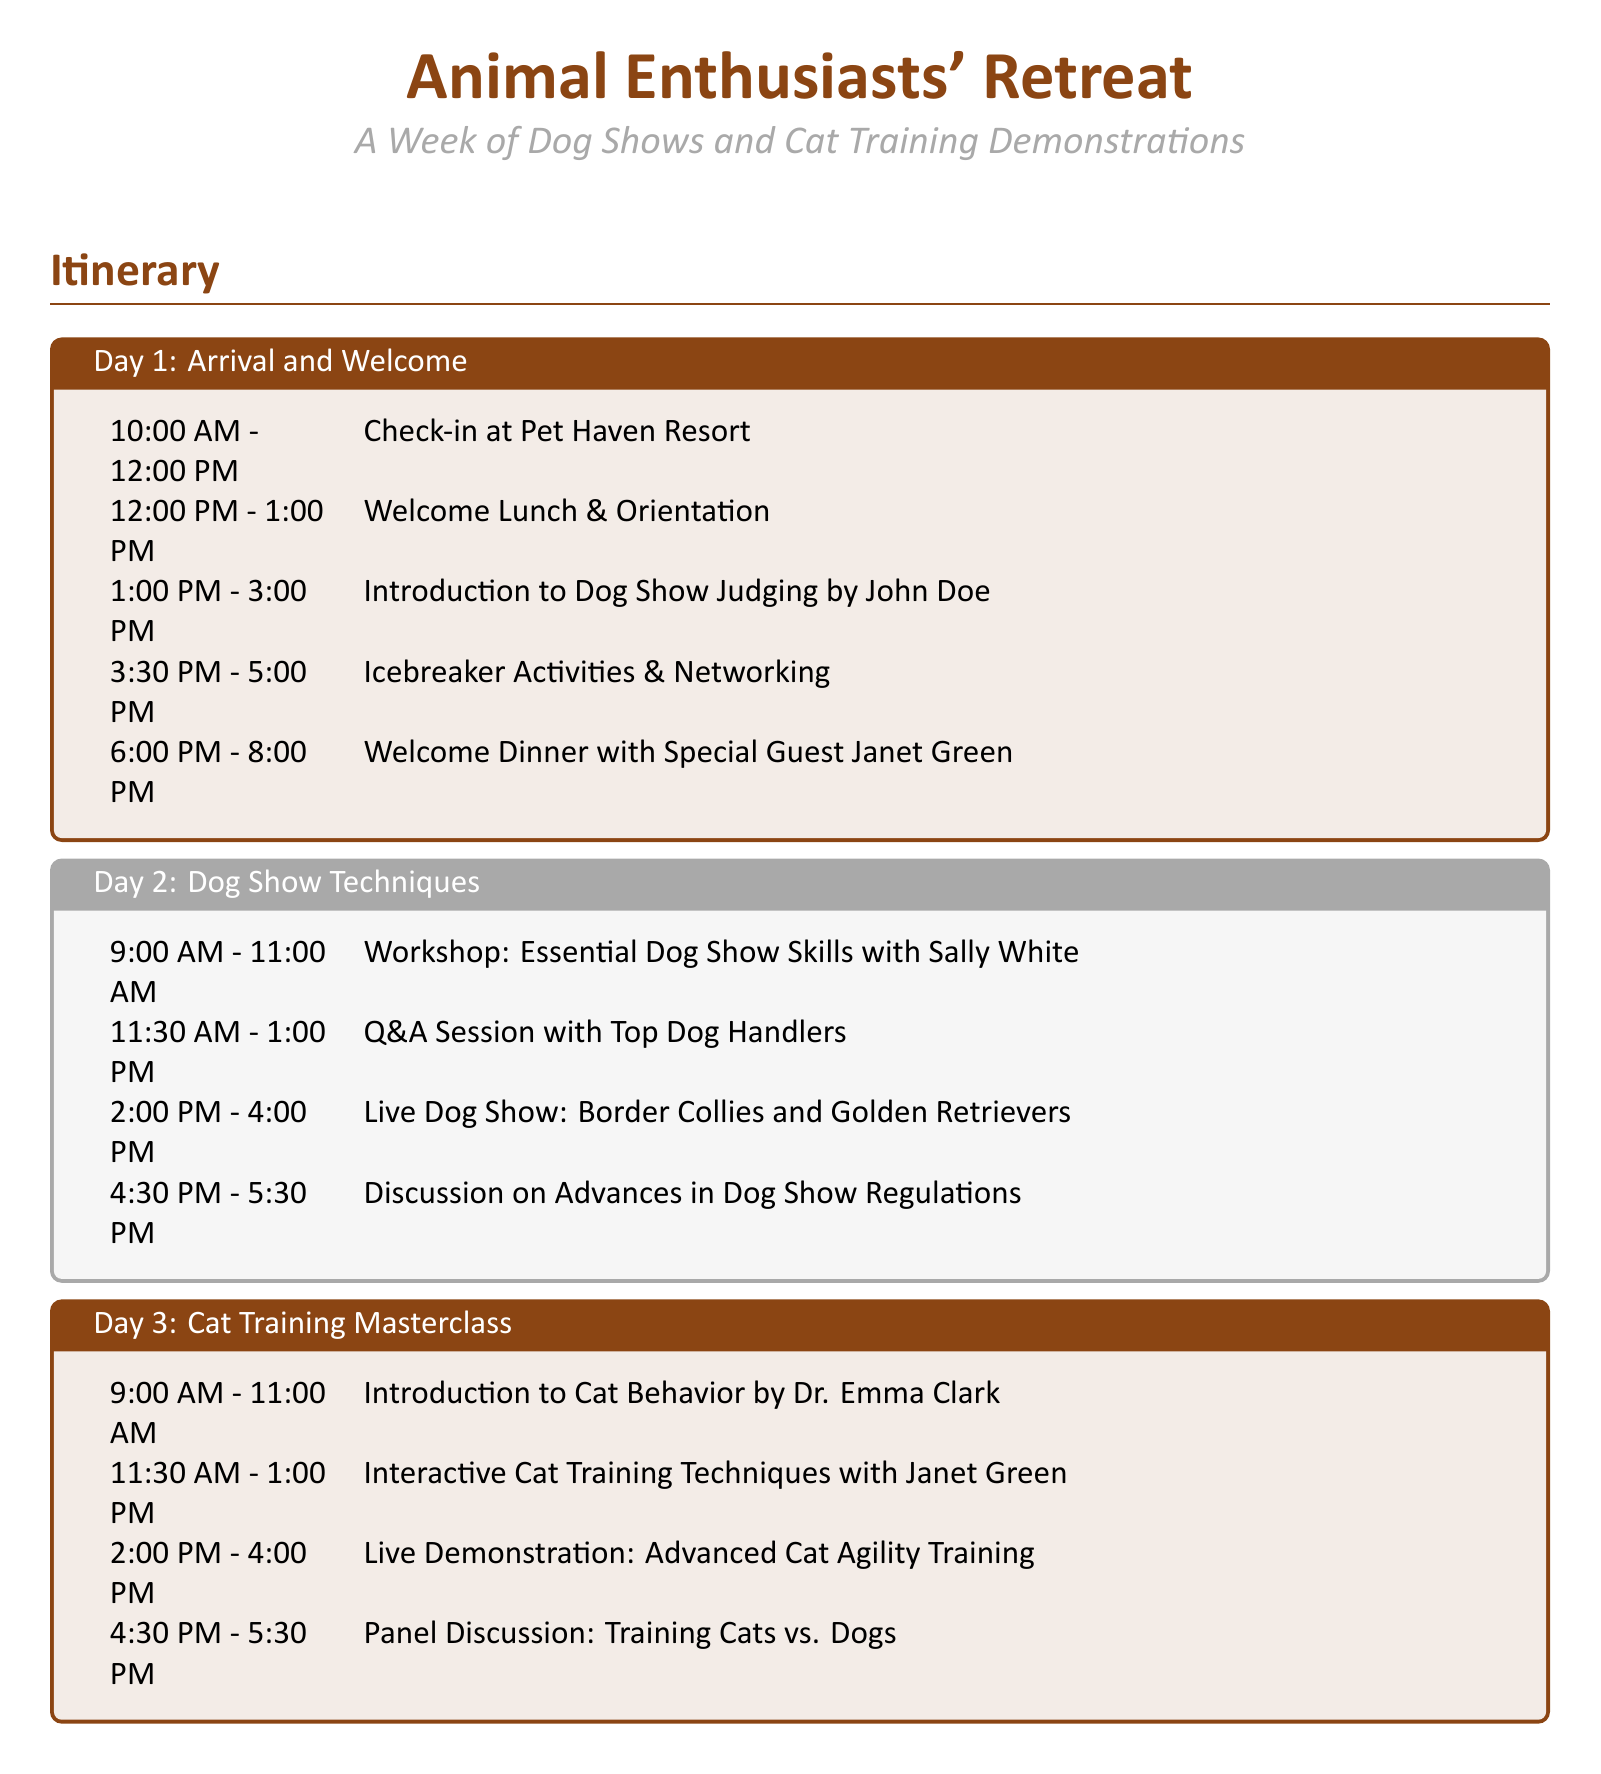What time is the welcome dinner? The welcome dinner is scheduled for 6:00 PM to 8:00 PM on Day 1.
Answer: 6:00 PM - 8:00 PM Who is leading the workshop on Dog Show Techniques? The workshop on Dog Show Techniques is being led by Sally White.
Answer: Sally White What is the topic of the panel discussion on Day 3? The topic of the panel discussion on Day 3 is "Training Cats vs. Dogs."
Answer: Training Cats vs. Dogs How long is the Joint Workshop on Day 4? The Joint Workshop on Day 4 is from 2:00 PM to 4:00 PM, hence lasting 2 hours.
Answer: 2 hours Which day features a live demonstration of parrot training? The live demonstration of parrot training is on Day 5.
Answer: Day 5 What event occurs before the Closing Ceremony on Day 6? Before the Closing Ceremony, there is a preparation session from 10:30 AM to 12:00 PM.
Answer: Preparation for Closing Ceremony How many hours are allocated for the feedback session on Day 6? The feedback session on Day 6 lasts for 1 hour, from 9:00 AM to 10:00 AM.
Answer: 1 hour What activity is scheduled after the Engaging Pet Tricks Competition on Day 4? After the Engaging Pet Tricks Competition, there is a joint workshop.
Answer: Joint Workshop: Multi-Species Training Program 